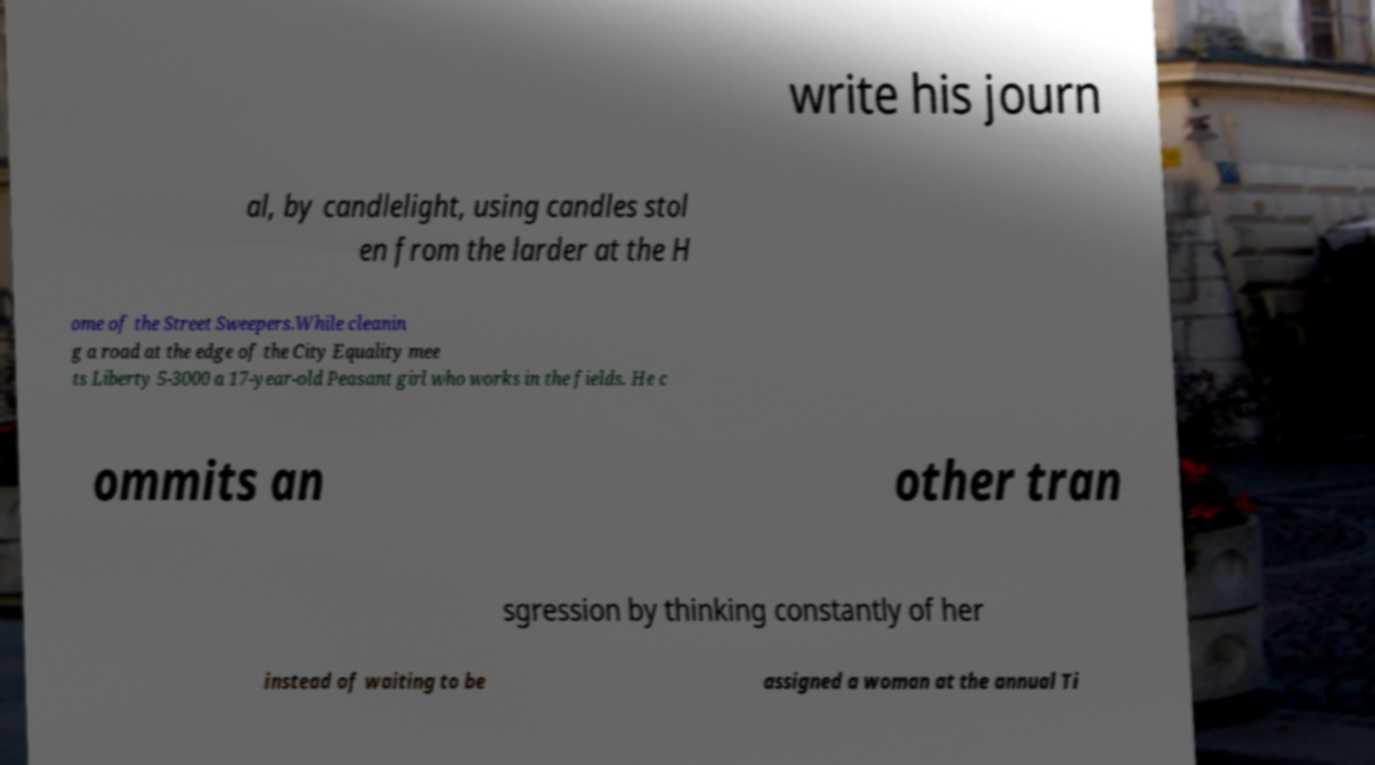Can you read and provide the text displayed in the image?This photo seems to have some interesting text. Can you extract and type it out for me? write his journ al, by candlelight, using candles stol en from the larder at the H ome of the Street Sweepers.While cleanin g a road at the edge of the City Equality mee ts Liberty 5-3000 a 17-year-old Peasant girl who works in the fields. He c ommits an other tran sgression by thinking constantly of her instead of waiting to be assigned a woman at the annual Ti 